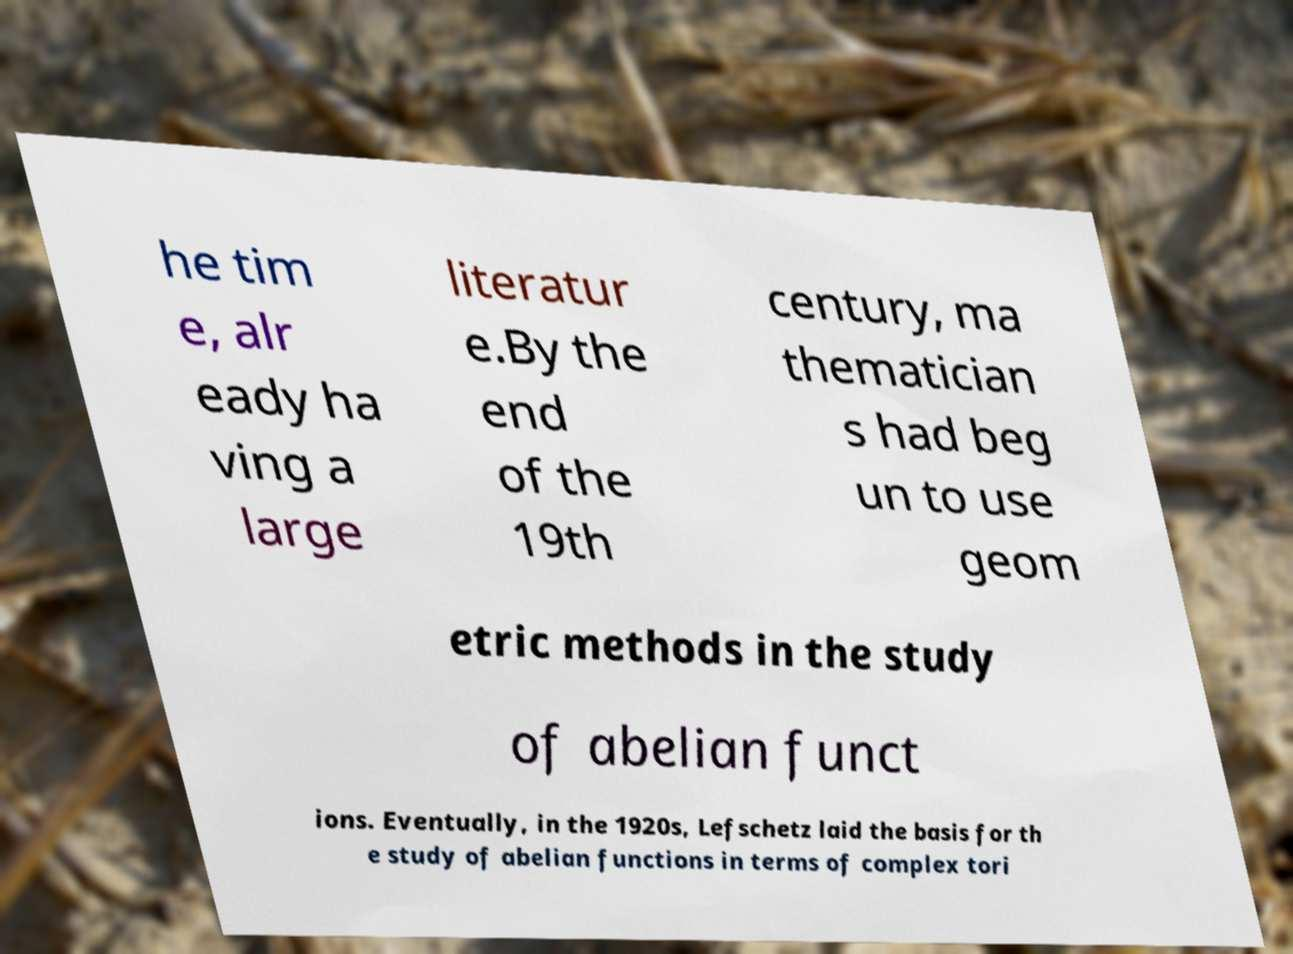Can you read and provide the text displayed in the image?This photo seems to have some interesting text. Can you extract and type it out for me? he tim e, alr eady ha ving a large literatur e.By the end of the 19th century, ma thematician s had beg un to use geom etric methods in the study of abelian funct ions. Eventually, in the 1920s, Lefschetz laid the basis for th e study of abelian functions in terms of complex tori 